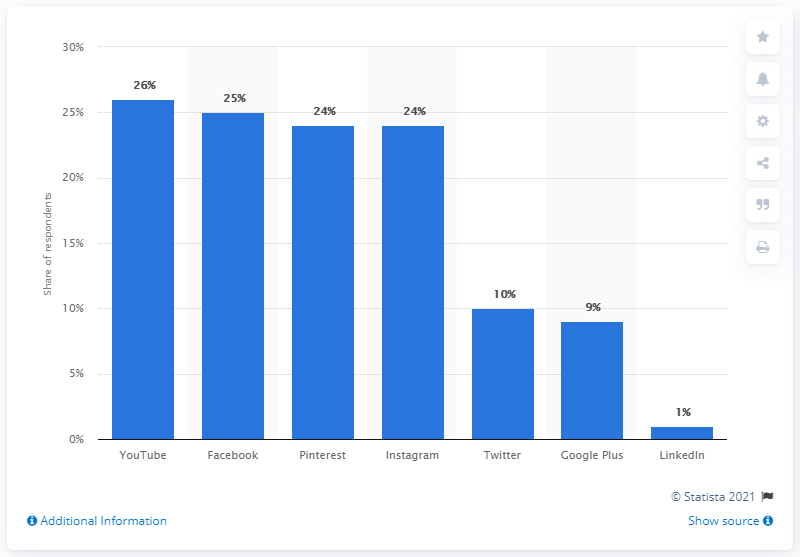Give some essential details in this illustration. In a survey of female respondents, 26% named YouTube as a social media channel that influenced their purchase decisions. 